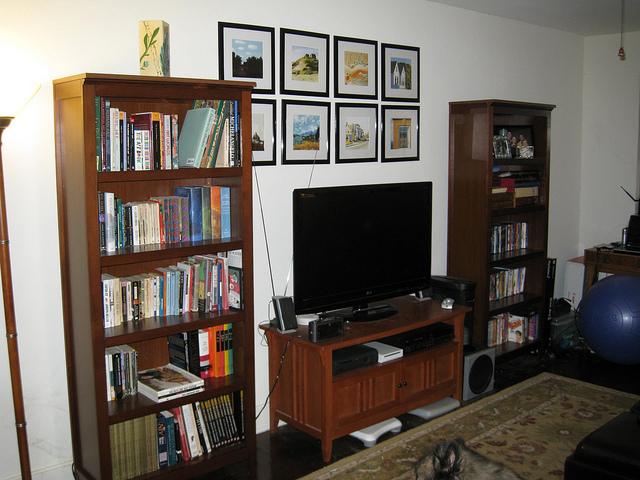Is this where I would cook bacon?
Keep it brief. No. Is the television turned on?
Short answer required. No. Is that an LCD TV?
Answer briefly. Yes. Is the television on?
Keep it brief. No. What it is bedroom or drawing room?
Give a very brief answer. Drawing room. Is the tv on?
Be succinct. No. What is written at the bottom left of the picture?
Answer briefly. Nothing. Does this bookshelf contain antique collectibles?
Answer briefly. No. 